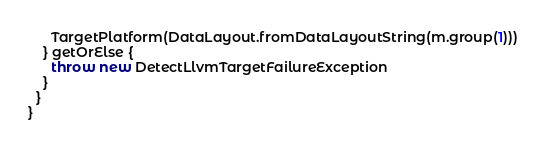Convert code to text. <code><loc_0><loc_0><loc_500><loc_500><_Scala_>      TargetPlatform(DataLayout.fromDataLayoutString(m.group(1)))
    } getOrElse {
      throw new DetectLlvmTargetFailureException
    }
  }
}
</code> 